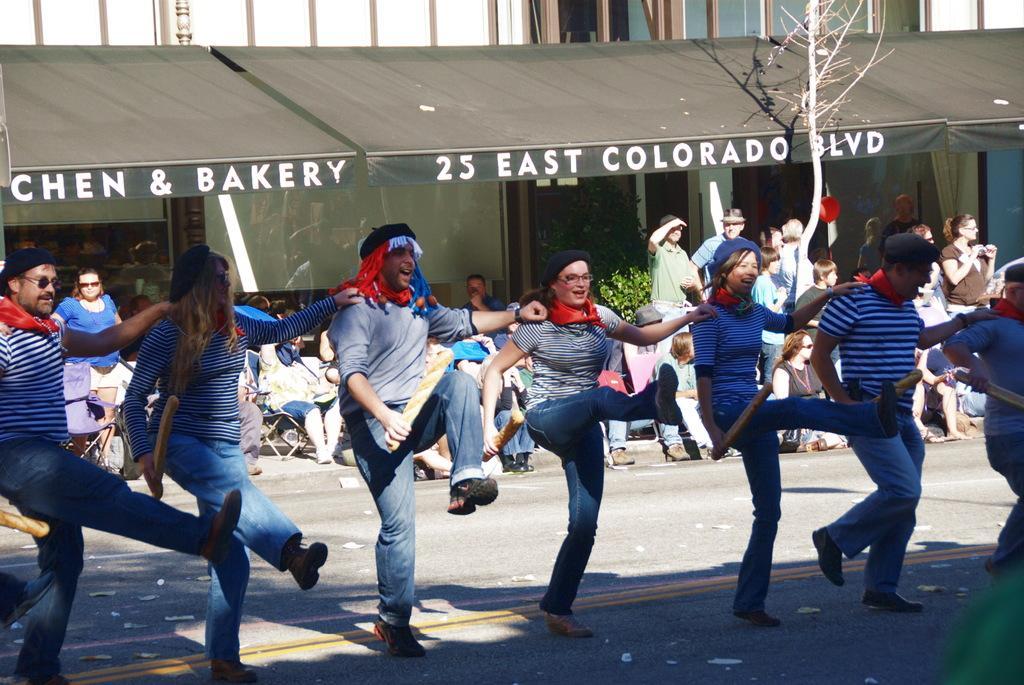Could you give a brief overview of what you see in this image? In this image we can see people dancing. They are holding breads. In the background there is crowd sitting and some of them are standing. On the right there is a tree and we can see a shed. There is a plant. 